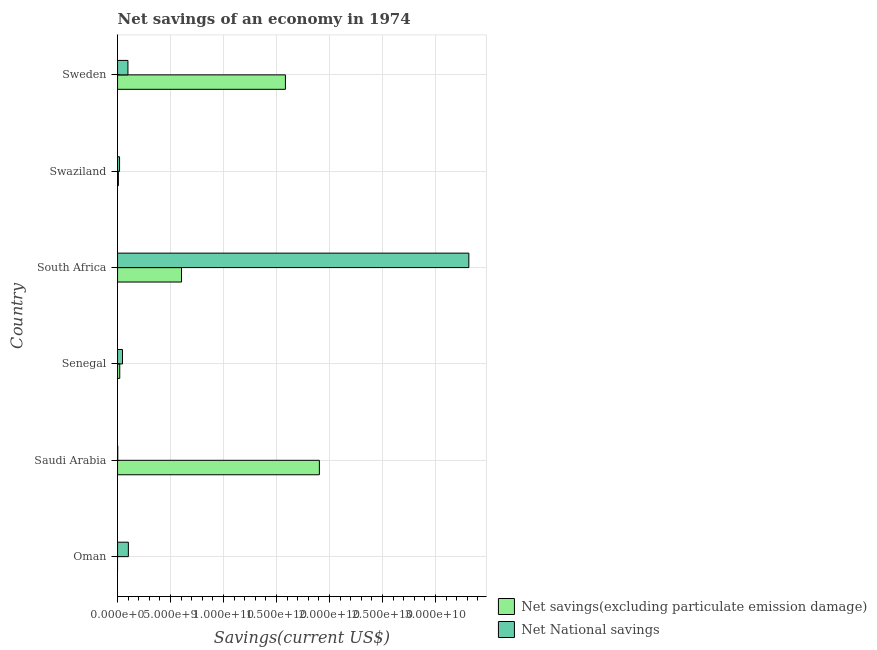How many different coloured bars are there?
Keep it short and to the point. 2. Are the number of bars per tick equal to the number of legend labels?
Keep it short and to the point. No. How many bars are there on the 1st tick from the top?
Your answer should be very brief. 2. How many bars are there on the 6th tick from the bottom?
Provide a short and direct response. 2. What is the label of the 4th group of bars from the top?
Offer a terse response. Senegal. What is the net national savings in South Africa?
Your response must be concise. 3.32e+1. Across all countries, what is the maximum net savings(excluding particulate emission damage)?
Provide a short and direct response. 1.90e+1. Across all countries, what is the minimum net national savings?
Provide a short and direct response. 1.78e+07. In which country was the net savings(excluding particulate emission damage) maximum?
Keep it short and to the point. Saudi Arabia. What is the total net savings(excluding particulate emission damage) in the graph?
Offer a very short reply. 4.12e+1. What is the difference between the net national savings in Saudi Arabia and that in Senegal?
Offer a very short reply. -4.48e+08. What is the difference between the net national savings in Senegal and the net savings(excluding particulate emission damage) in Oman?
Provide a succinct answer. 4.66e+08. What is the average net national savings per country?
Offer a terse response. 5.97e+09. What is the difference between the net national savings and net savings(excluding particulate emission damage) in Senegal?
Provide a succinct answer. 2.60e+08. What is the ratio of the net savings(excluding particulate emission damage) in South Africa to that in Sweden?
Provide a succinct answer. 0.38. What is the difference between the highest and the second highest net national savings?
Your response must be concise. 3.21e+1. What is the difference between the highest and the lowest net national savings?
Ensure brevity in your answer.  3.31e+1. In how many countries, is the net national savings greater than the average net national savings taken over all countries?
Keep it short and to the point. 1. Is the sum of the net national savings in Saudi Arabia and Senegal greater than the maximum net savings(excluding particulate emission damage) across all countries?
Ensure brevity in your answer.  No. How many bars are there?
Provide a short and direct response. 11. Are all the bars in the graph horizontal?
Your answer should be very brief. Yes. How many countries are there in the graph?
Give a very brief answer. 6. What is the difference between two consecutive major ticks on the X-axis?
Offer a terse response. 5.00e+09. Are the values on the major ticks of X-axis written in scientific E-notation?
Your answer should be very brief. Yes. Does the graph contain grids?
Offer a very short reply. Yes. Where does the legend appear in the graph?
Your answer should be compact. Bottom right. How many legend labels are there?
Provide a succinct answer. 2. How are the legend labels stacked?
Keep it short and to the point. Vertical. What is the title of the graph?
Provide a short and direct response. Net savings of an economy in 1974. What is the label or title of the X-axis?
Ensure brevity in your answer.  Savings(current US$). What is the label or title of the Y-axis?
Give a very brief answer. Country. What is the Savings(current US$) of Net savings(excluding particulate emission damage) in Oman?
Your answer should be compact. 0. What is the Savings(current US$) of Net National savings in Oman?
Keep it short and to the point. 1.02e+09. What is the Savings(current US$) of Net savings(excluding particulate emission damage) in Saudi Arabia?
Ensure brevity in your answer.  1.90e+1. What is the Savings(current US$) in Net National savings in Saudi Arabia?
Make the answer very short. 1.78e+07. What is the Savings(current US$) in Net savings(excluding particulate emission damage) in Senegal?
Your answer should be very brief. 2.06e+08. What is the Savings(current US$) of Net National savings in Senegal?
Offer a terse response. 4.66e+08. What is the Savings(current US$) of Net savings(excluding particulate emission damage) in South Africa?
Keep it short and to the point. 6.04e+09. What is the Savings(current US$) of Net National savings in South Africa?
Your answer should be compact. 3.32e+1. What is the Savings(current US$) of Net savings(excluding particulate emission damage) in Swaziland?
Provide a short and direct response. 7.66e+07. What is the Savings(current US$) of Net National savings in Swaziland?
Make the answer very short. 1.90e+08. What is the Savings(current US$) of Net savings(excluding particulate emission damage) in Sweden?
Your answer should be very brief. 1.58e+1. What is the Savings(current US$) in Net National savings in Sweden?
Your answer should be very brief. 9.80e+08. Across all countries, what is the maximum Savings(current US$) of Net savings(excluding particulate emission damage)?
Make the answer very short. 1.90e+1. Across all countries, what is the maximum Savings(current US$) of Net National savings?
Offer a terse response. 3.32e+1. Across all countries, what is the minimum Savings(current US$) of Net savings(excluding particulate emission damage)?
Offer a very short reply. 0. Across all countries, what is the minimum Savings(current US$) of Net National savings?
Your response must be concise. 1.78e+07. What is the total Savings(current US$) in Net savings(excluding particulate emission damage) in the graph?
Make the answer very short. 4.12e+1. What is the total Savings(current US$) of Net National savings in the graph?
Your answer should be compact. 3.58e+1. What is the difference between the Savings(current US$) in Net National savings in Oman and that in Saudi Arabia?
Provide a short and direct response. 1.00e+09. What is the difference between the Savings(current US$) of Net National savings in Oman and that in Senegal?
Your response must be concise. 5.54e+08. What is the difference between the Savings(current US$) of Net National savings in Oman and that in South Africa?
Offer a very short reply. -3.21e+1. What is the difference between the Savings(current US$) of Net National savings in Oman and that in Swaziland?
Make the answer very short. 8.30e+08. What is the difference between the Savings(current US$) in Net National savings in Oman and that in Sweden?
Ensure brevity in your answer.  4.02e+07. What is the difference between the Savings(current US$) of Net savings(excluding particulate emission damage) in Saudi Arabia and that in Senegal?
Keep it short and to the point. 1.88e+1. What is the difference between the Savings(current US$) of Net National savings in Saudi Arabia and that in Senegal?
Provide a short and direct response. -4.48e+08. What is the difference between the Savings(current US$) of Net savings(excluding particulate emission damage) in Saudi Arabia and that in South Africa?
Give a very brief answer. 1.30e+1. What is the difference between the Savings(current US$) of Net National savings in Saudi Arabia and that in South Africa?
Provide a short and direct response. -3.31e+1. What is the difference between the Savings(current US$) of Net savings(excluding particulate emission damage) in Saudi Arabia and that in Swaziland?
Give a very brief answer. 1.90e+1. What is the difference between the Savings(current US$) in Net National savings in Saudi Arabia and that in Swaziland?
Provide a succinct answer. -1.72e+08. What is the difference between the Savings(current US$) of Net savings(excluding particulate emission damage) in Saudi Arabia and that in Sweden?
Ensure brevity in your answer.  3.20e+09. What is the difference between the Savings(current US$) of Net National savings in Saudi Arabia and that in Sweden?
Give a very brief answer. -9.62e+08. What is the difference between the Savings(current US$) in Net savings(excluding particulate emission damage) in Senegal and that in South Africa?
Make the answer very short. -5.83e+09. What is the difference between the Savings(current US$) of Net National savings in Senegal and that in South Africa?
Your answer should be very brief. -3.27e+1. What is the difference between the Savings(current US$) in Net savings(excluding particulate emission damage) in Senegal and that in Swaziland?
Keep it short and to the point. 1.30e+08. What is the difference between the Savings(current US$) of Net National savings in Senegal and that in Swaziland?
Offer a terse response. 2.76e+08. What is the difference between the Savings(current US$) in Net savings(excluding particulate emission damage) in Senegal and that in Sweden?
Offer a terse response. -1.56e+1. What is the difference between the Savings(current US$) in Net National savings in Senegal and that in Sweden?
Offer a very short reply. -5.14e+08. What is the difference between the Savings(current US$) of Net savings(excluding particulate emission damage) in South Africa and that in Swaziland?
Give a very brief answer. 5.96e+09. What is the difference between the Savings(current US$) in Net National savings in South Africa and that in Swaziland?
Give a very brief answer. 3.30e+1. What is the difference between the Savings(current US$) of Net savings(excluding particulate emission damage) in South Africa and that in Sweden?
Give a very brief answer. -9.81e+09. What is the difference between the Savings(current US$) in Net National savings in South Africa and that in Sweden?
Your answer should be very brief. 3.22e+1. What is the difference between the Savings(current US$) of Net savings(excluding particulate emission damage) in Swaziland and that in Sweden?
Your answer should be compact. -1.58e+1. What is the difference between the Savings(current US$) in Net National savings in Swaziland and that in Sweden?
Keep it short and to the point. -7.90e+08. What is the difference between the Savings(current US$) in Net savings(excluding particulate emission damage) in Saudi Arabia and the Savings(current US$) in Net National savings in Senegal?
Your answer should be compact. 1.86e+1. What is the difference between the Savings(current US$) in Net savings(excluding particulate emission damage) in Saudi Arabia and the Savings(current US$) in Net National savings in South Africa?
Offer a very short reply. -1.41e+1. What is the difference between the Savings(current US$) of Net savings(excluding particulate emission damage) in Saudi Arabia and the Savings(current US$) of Net National savings in Swaziland?
Your answer should be compact. 1.89e+1. What is the difference between the Savings(current US$) of Net savings(excluding particulate emission damage) in Saudi Arabia and the Savings(current US$) of Net National savings in Sweden?
Provide a short and direct response. 1.81e+1. What is the difference between the Savings(current US$) of Net savings(excluding particulate emission damage) in Senegal and the Savings(current US$) of Net National savings in South Africa?
Offer a very short reply. -3.29e+1. What is the difference between the Savings(current US$) of Net savings(excluding particulate emission damage) in Senegal and the Savings(current US$) of Net National savings in Swaziland?
Your response must be concise. 1.64e+07. What is the difference between the Savings(current US$) of Net savings(excluding particulate emission damage) in Senegal and the Savings(current US$) of Net National savings in Sweden?
Ensure brevity in your answer.  -7.74e+08. What is the difference between the Savings(current US$) in Net savings(excluding particulate emission damage) in South Africa and the Savings(current US$) in Net National savings in Swaziland?
Ensure brevity in your answer.  5.85e+09. What is the difference between the Savings(current US$) of Net savings(excluding particulate emission damage) in South Africa and the Savings(current US$) of Net National savings in Sweden?
Provide a succinct answer. 5.06e+09. What is the difference between the Savings(current US$) of Net savings(excluding particulate emission damage) in Swaziland and the Savings(current US$) of Net National savings in Sweden?
Offer a terse response. -9.03e+08. What is the average Savings(current US$) in Net savings(excluding particulate emission damage) per country?
Make the answer very short. 6.87e+09. What is the average Savings(current US$) in Net National savings per country?
Provide a succinct answer. 5.97e+09. What is the difference between the Savings(current US$) in Net savings(excluding particulate emission damage) and Savings(current US$) in Net National savings in Saudi Arabia?
Provide a succinct answer. 1.90e+1. What is the difference between the Savings(current US$) of Net savings(excluding particulate emission damage) and Savings(current US$) of Net National savings in Senegal?
Offer a terse response. -2.60e+08. What is the difference between the Savings(current US$) of Net savings(excluding particulate emission damage) and Savings(current US$) of Net National savings in South Africa?
Keep it short and to the point. -2.71e+1. What is the difference between the Savings(current US$) of Net savings(excluding particulate emission damage) and Savings(current US$) of Net National savings in Swaziland?
Give a very brief answer. -1.13e+08. What is the difference between the Savings(current US$) in Net savings(excluding particulate emission damage) and Savings(current US$) in Net National savings in Sweden?
Provide a succinct answer. 1.49e+1. What is the ratio of the Savings(current US$) of Net National savings in Oman to that in Saudi Arabia?
Provide a succinct answer. 57.19. What is the ratio of the Savings(current US$) of Net National savings in Oman to that in Senegal?
Offer a very short reply. 2.19. What is the ratio of the Savings(current US$) of Net National savings in Oman to that in South Africa?
Your answer should be very brief. 0.03. What is the ratio of the Savings(current US$) in Net National savings in Oman to that in Swaziland?
Ensure brevity in your answer.  5.37. What is the ratio of the Savings(current US$) in Net National savings in Oman to that in Sweden?
Provide a short and direct response. 1.04. What is the ratio of the Savings(current US$) of Net savings(excluding particulate emission damage) in Saudi Arabia to that in Senegal?
Keep it short and to the point. 92.34. What is the ratio of the Savings(current US$) in Net National savings in Saudi Arabia to that in Senegal?
Ensure brevity in your answer.  0.04. What is the ratio of the Savings(current US$) of Net savings(excluding particulate emission damage) in Saudi Arabia to that in South Africa?
Your answer should be compact. 3.16. What is the ratio of the Savings(current US$) in Net savings(excluding particulate emission damage) in Saudi Arabia to that in Swaziland?
Your answer should be very brief. 248.72. What is the ratio of the Savings(current US$) of Net National savings in Saudi Arabia to that in Swaziland?
Give a very brief answer. 0.09. What is the ratio of the Savings(current US$) in Net savings(excluding particulate emission damage) in Saudi Arabia to that in Sweden?
Your response must be concise. 1.2. What is the ratio of the Savings(current US$) of Net National savings in Saudi Arabia to that in Sweden?
Offer a terse response. 0.02. What is the ratio of the Savings(current US$) in Net savings(excluding particulate emission damage) in Senegal to that in South Africa?
Provide a short and direct response. 0.03. What is the ratio of the Savings(current US$) of Net National savings in Senegal to that in South Africa?
Ensure brevity in your answer.  0.01. What is the ratio of the Savings(current US$) in Net savings(excluding particulate emission damage) in Senegal to that in Swaziland?
Offer a very short reply. 2.69. What is the ratio of the Savings(current US$) of Net National savings in Senegal to that in Swaziland?
Ensure brevity in your answer.  2.45. What is the ratio of the Savings(current US$) of Net savings(excluding particulate emission damage) in Senegal to that in Sweden?
Keep it short and to the point. 0.01. What is the ratio of the Savings(current US$) in Net National savings in Senegal to that in Sweden?
Give a very brief answer. 0.48. What is the ratio of the Savings(current US$) of Net savings(excluding particulate emission damage) in South Africa to that in Swaziland?
Provide a succinct answer. 78.82. What is the ratio of the Savings(current US$) in Net National savings in South Africa to that in Swaziland?
Your response must be concise. 174.61. What is the ratio of the Savings(current US$) of Net savings(excluding particulate emission damage) in South Africa to that in Sweden?
Keep it short and to the point. 0.38. What is the ratio of the Savings(current US$) of Net National savings in South Africa to that in Sweden?
Provide a short and direct response. 33.83. What is the ratio of the Savings(current US$) in Net savings(excluding particulate emission damage) in Swaziland to that in Sweden?
Your response must be concise. 0. What is the ratio of the Savings(current US$) in Net National savings in Swaziland to that in Sweden?
Provide a succinct answer. 0.19. What is the difference between the highest and the second highest Savings(current US$) of Net savings(excluding particulate emission damage)?
Offer a terse response. 3.20e+09. What is the difference between the highest and the second highest Savings(current US$) in Net National savings?
Give a very brief answer. 3.21e+1. What is the difference between the highest and the lowest Savings(current US$) in Net savings(excluding particulate emission damage)?
Offer a terse response. 1.90e+1. What is the difference between the highest and the lowest Savings(current US$) in Net National savings?
Make the answer very short. 3.31e+1. 